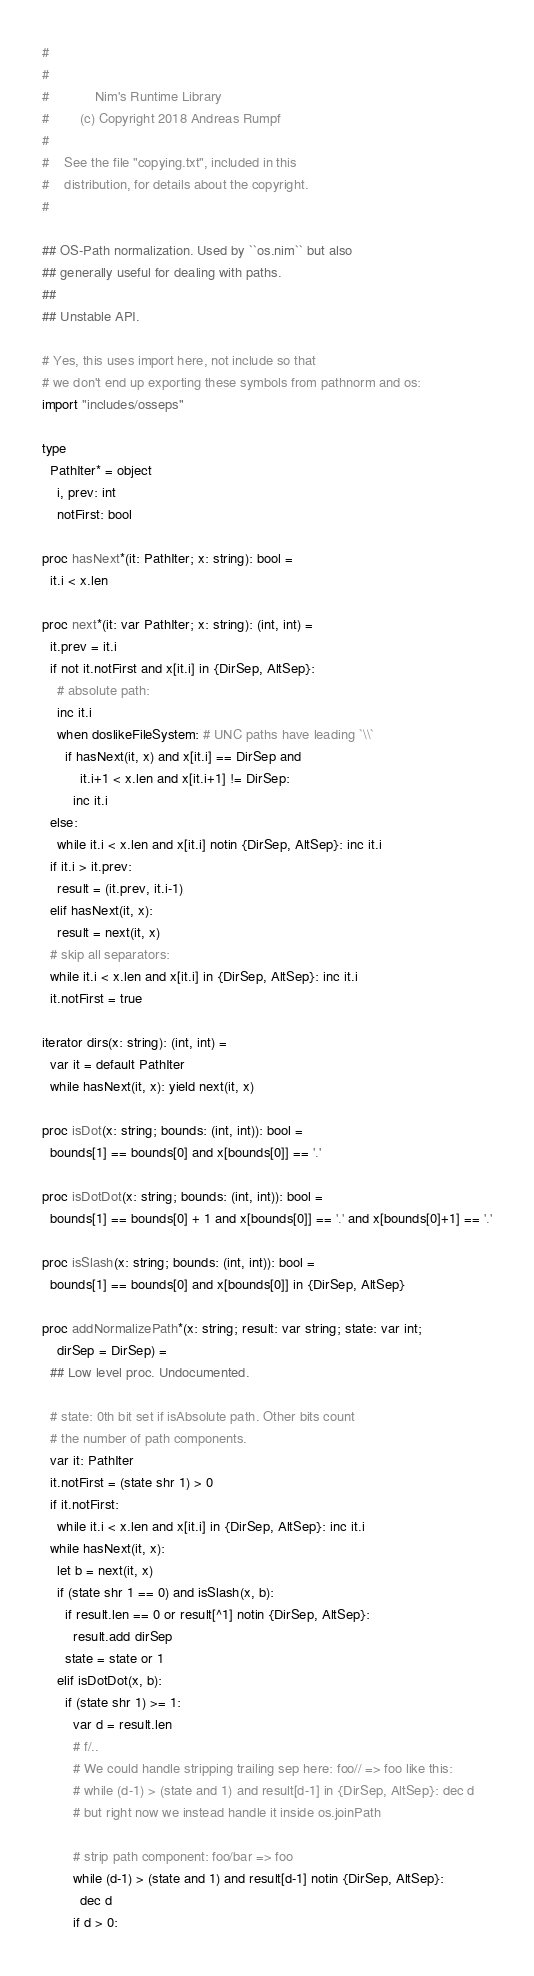Convert code to text. <code><loc_0><loc_0><loc_500><loc_500><_Nim_>#
#
#            Nim's Runtime Library
#        (c) Copyright 2018 Andreas Rumpf
#
#    See the file "copying.txt", included in this
#    distribution, for details about the copyright.
#

## OS-Path normalization. Used by ``os.nim`` but also
## generally useful for dealing with paths.
##
## Unstable API.

# Yes, this uses import here, not include so that
# we don't end up exporting these symbols from pathnorm and os:
import "includes/osseps"

type
  PathIter* = object
    i, prev: int
    notFirst: bool

proc hasNext*(it: PathIter; x: string): bool =
  it.i < x.len

proc next*(it: var PathIter; x: string): (int, int) =
  it.prev = it.i
  if not it.notFirst and x[it.i] in {DirSep, AltSep}:
    # absolute path:
    inc it.i
    when doslikeFileSystem: # UNC paths have leading `\\`
      if hasNext(it, x) and x[it.i] == DirSep and
          it.i+1 < x.len and x[it.i+1] != DirSep:
        inc it.i
  else:
    while it.i < x.len and x[it.i] notin {DirSep, AltSep}: inc it.i
  if it.i > it.prev:
    result = (it.prev, it.i-1)
  elif hasNext(it, x):
    result = next(it, x)
  # skip all separators:
  while it.i < x.len and x[it.i] in {DirSep, AltSep}: inc it.i
  it.notFirst = true

iterator dirs(x: string): (int, int) =
  var it = default PathIter
  while hasNext(it, x): yield next(it, x)

proc isDot(x: string; bounds: (int, int)): bool =
  bounds[1] == bounds[0] and x[bounds[0]] == '.'

proc isDotDot(x: string; bounds: (int, int)): bool =
  bounds[1] == bounds[0] + 1 and x[bounds[0]] == '.' and x[bounds[0]+1] == '.'

proc isSlash(x: string; bounds: (int, int)): bool =
  bounds[1] == bounds[0] and x[bounds[0]] in {DirSep, AltSep}

proc addNormalizePath*(x: string; result: var string; state: var int;
    dirSep = DirSep) =
  ## Low level proc. Undocumented.

  # state: 0th bit set if isAbsolute path. Other bits count
  # the number of path components.
  var it: PathIter
  it.notFirst = (state shr 1) > 0
  if it.notFirst:
    while it.i < x.len and x[it.i] in {DirSep, AltSep}: inc it.i
  while hasNext(it, x):
    let b = next(it, x)
    if (state shr 1 == 0) and isSlash(x, b):
      if result.len == 0 or result[^1] notin {DirSep, AltSep}:
        result.add dirSep
      state = state or 1
    elif isDotDot(x, b):
      if (state shr 1) >= 1:
        var d = result.len
        # f/..
        # We could handle stripping trailing sep here: foo// => foo like this:
        # while (d-1) > (state and 1) and result[d-1] in {DirSep, AltSep}: dec d
        # but right now we instead handle it inside os.joinPath

        # strip path component: foo/bar => foo
        while (d-1) > (state and 1) and result[d-1] notin {DirSep, AltSep}:
          dec d
        if d > 0:</code> 